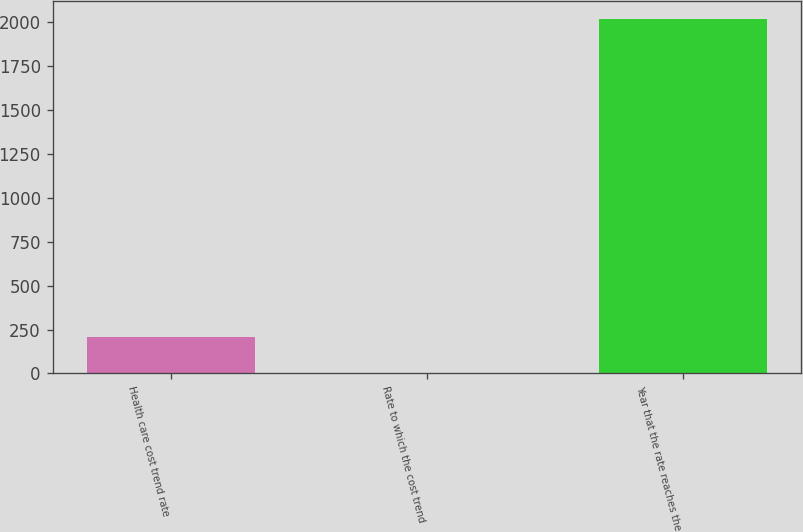Convert chart. <chart><loc_0><loc_0><loc_500><loc_500><bar_chart><fcel>Health care cost trend rate<fcel>Rate to which the cost trend<fcel>Year that the rate reaches the<nl><fcel>206.5<fcel>5<fcel>2020<nl></chart> 